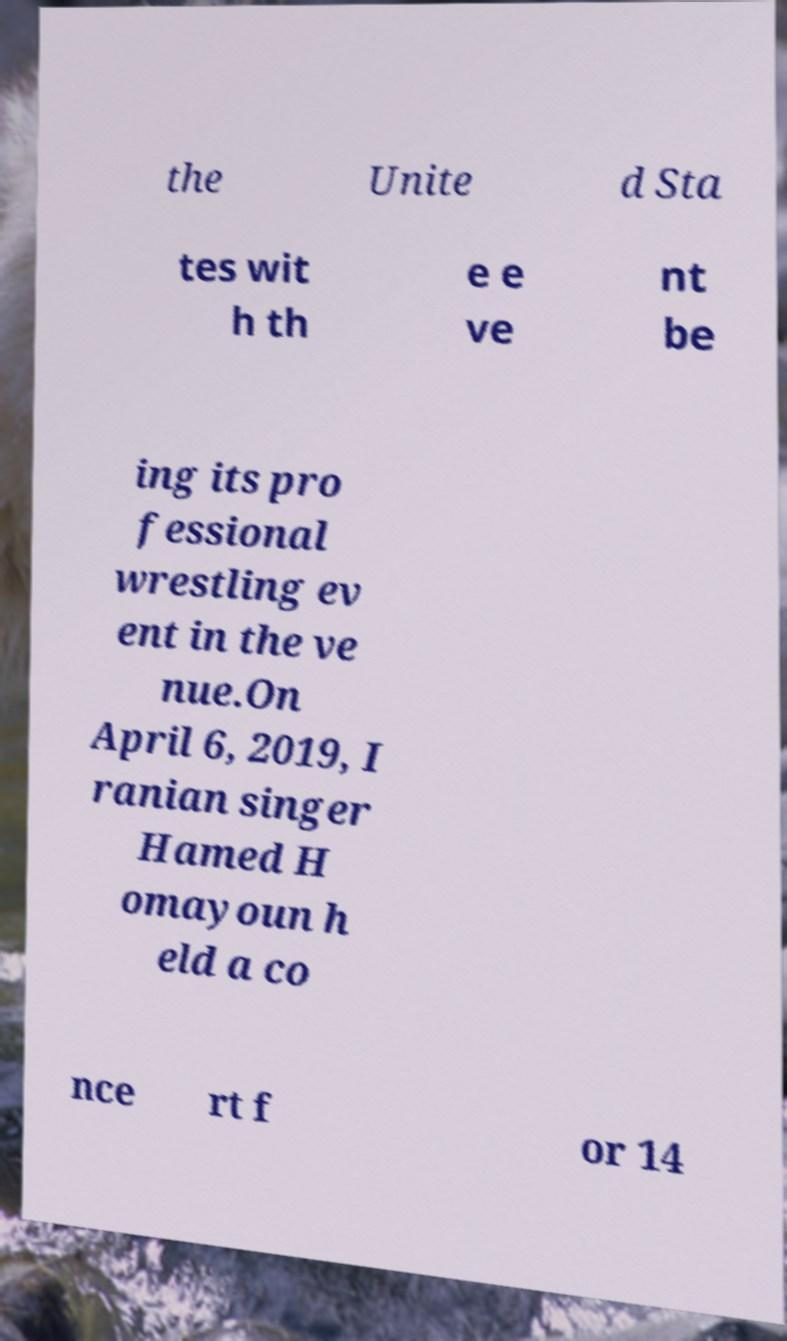Can you accurately transcribe the text from the provided image for me? the Unite d Sta tes wit h th e e ve nt be ing its pro fessional wrestling ev ent in the ve nue.On April 6, 2019, I ranian singer Hamed H omayoun h eld a co nce rt f or 14 